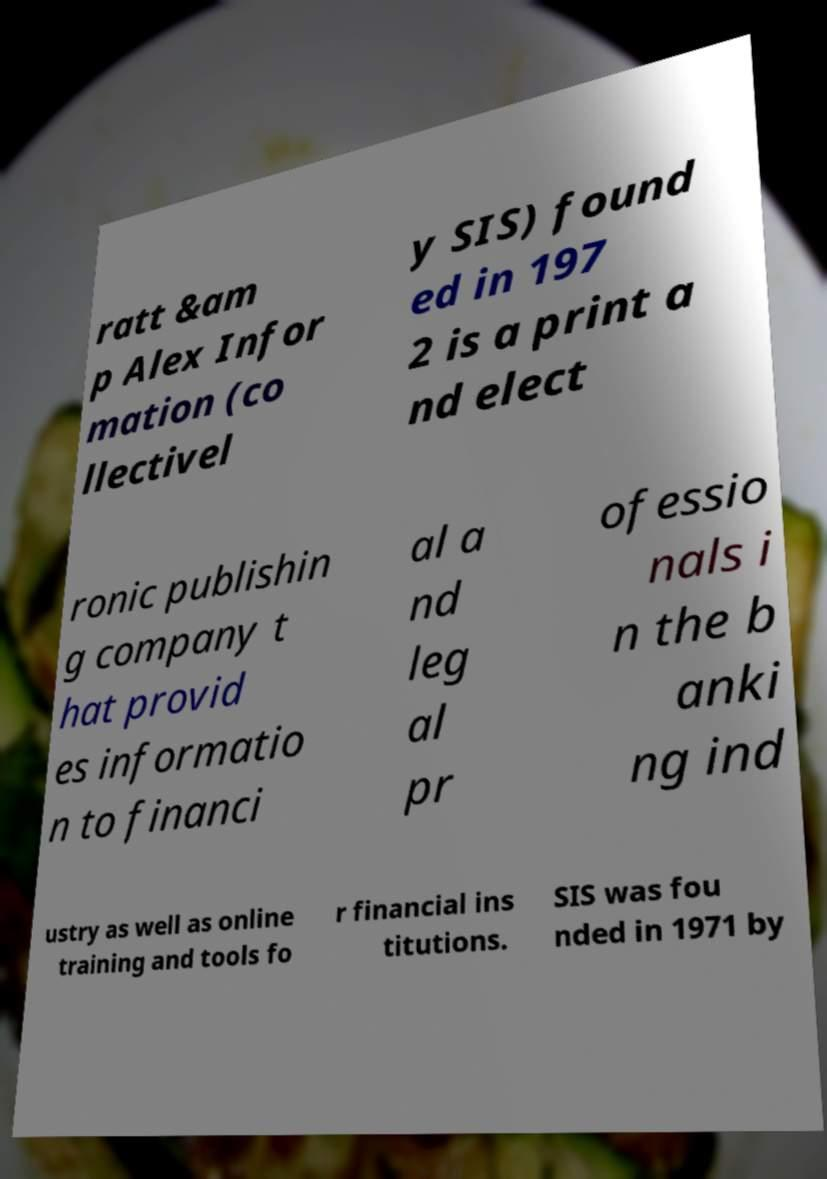I need the written content from this picture converted into text. Can you do that? ratt &am p Alex Infor mation (co llectivel y SIS) found ed in 197 2 is a print a nd elect ronic publishin g company t hat provid es informatio n to financi al a nd leg al pr ofessio nals i n the b anki ng ind ustry as well as online training and tools fo r financial ins titutions. SIS was fou nded in 1971 by 